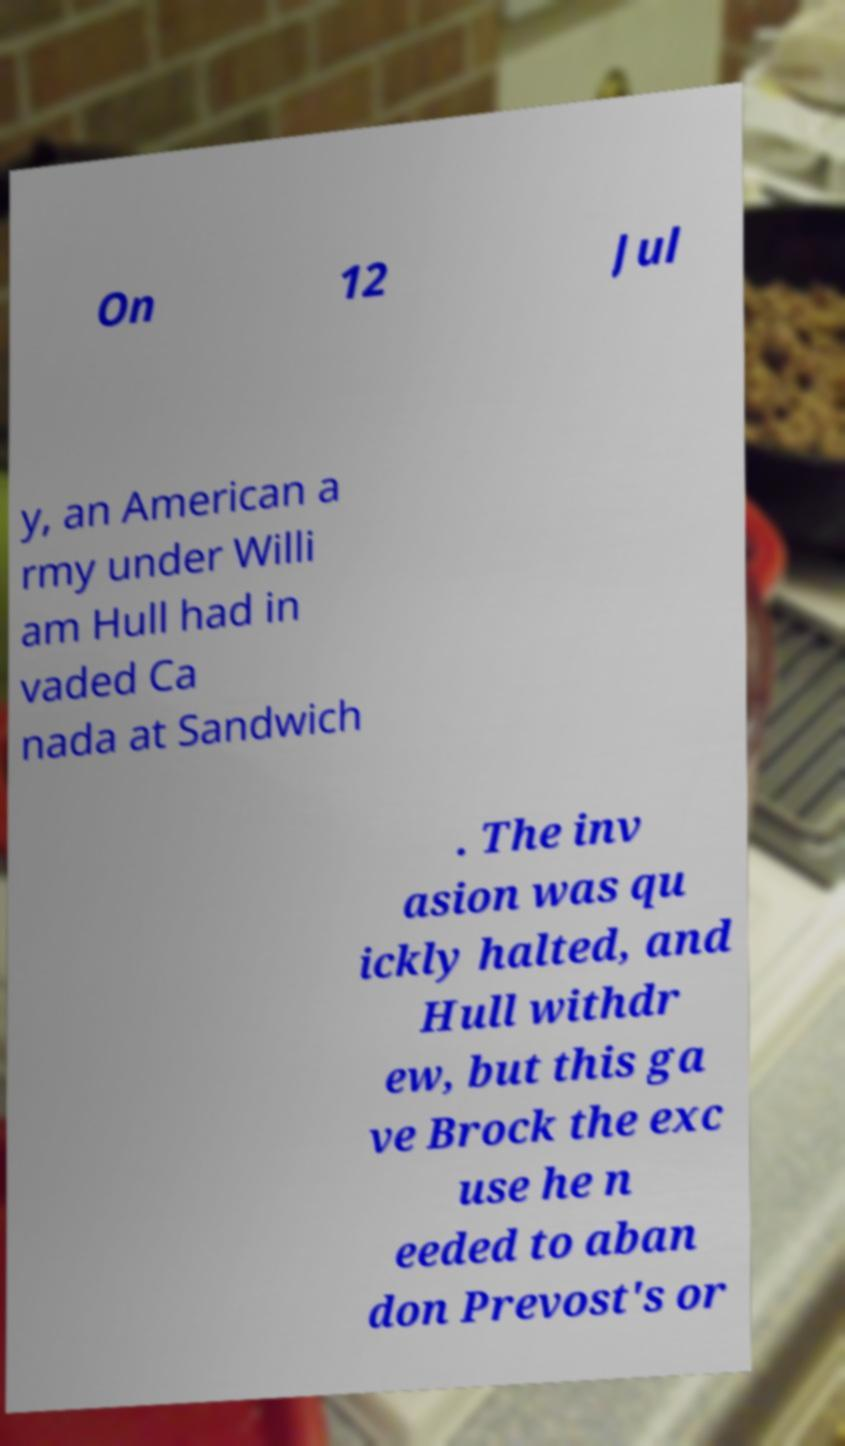There's text embedded in this image that I need extracted. Can you transcribe it verbatim? On 12 Jul y, an American a rmy under Willi am Hull had in vaded Ca nada at Sandwich . The inv asion was qu ickly halted, and Hull withdr ew, but this ga ve Brock the exc use he n eeded to aban don Prevost's or 